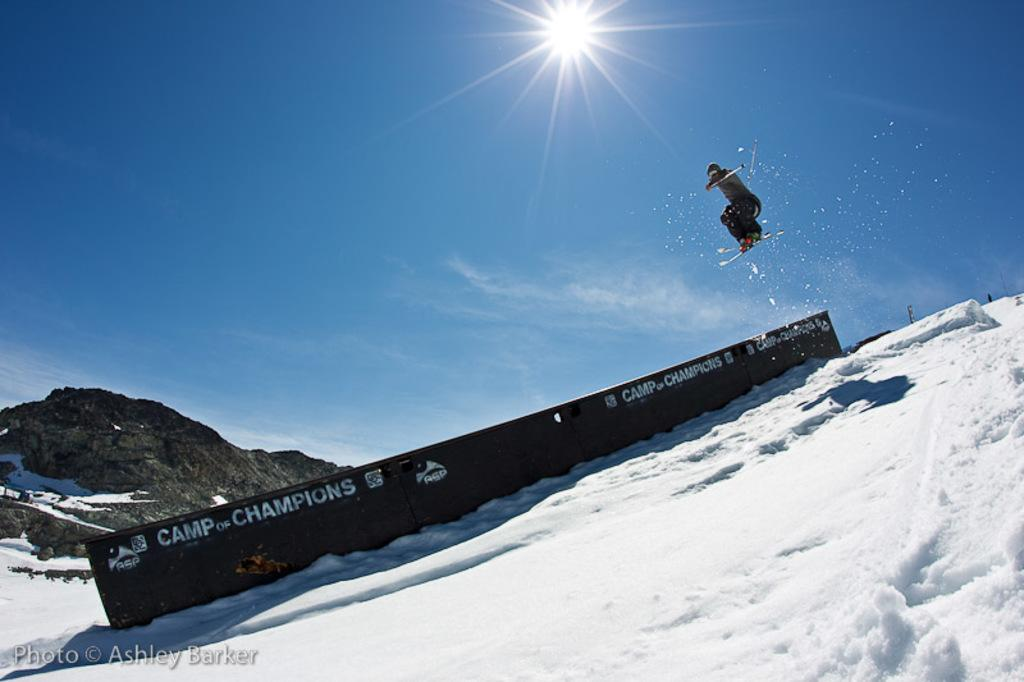<image>
Give a short and clear explanation of the subsequent image. A skier is in the air above a ramp that says Camp of Champions. 